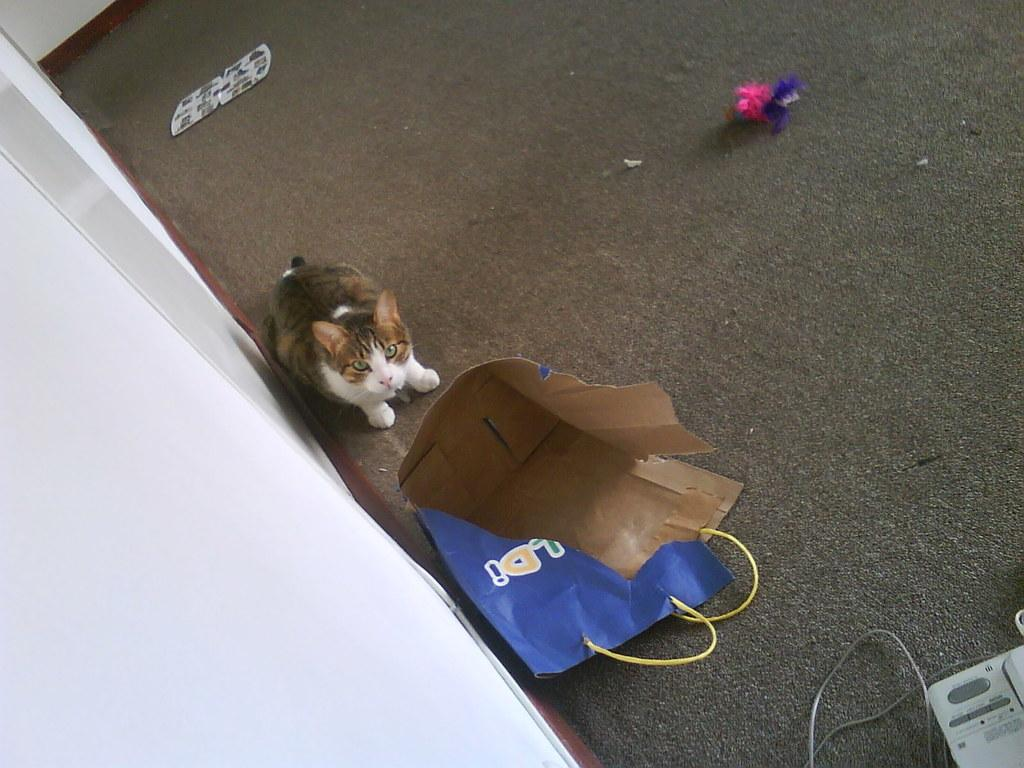What type of animal is in the image? There is a cat in the image. What object is also present in the image? There is a paper bag in the image. Where are the cat and the paper bag located in the image? Both the cat and the paper bag are in the center of the image. How many geese are swimming in the ocean in the image? There is no ocean or geese present in the image; it features a cat and a paper bag in the center. What type of key is being used by the cat in the image? There is no key present in the image; it features a cat and a paper bag in the center. 